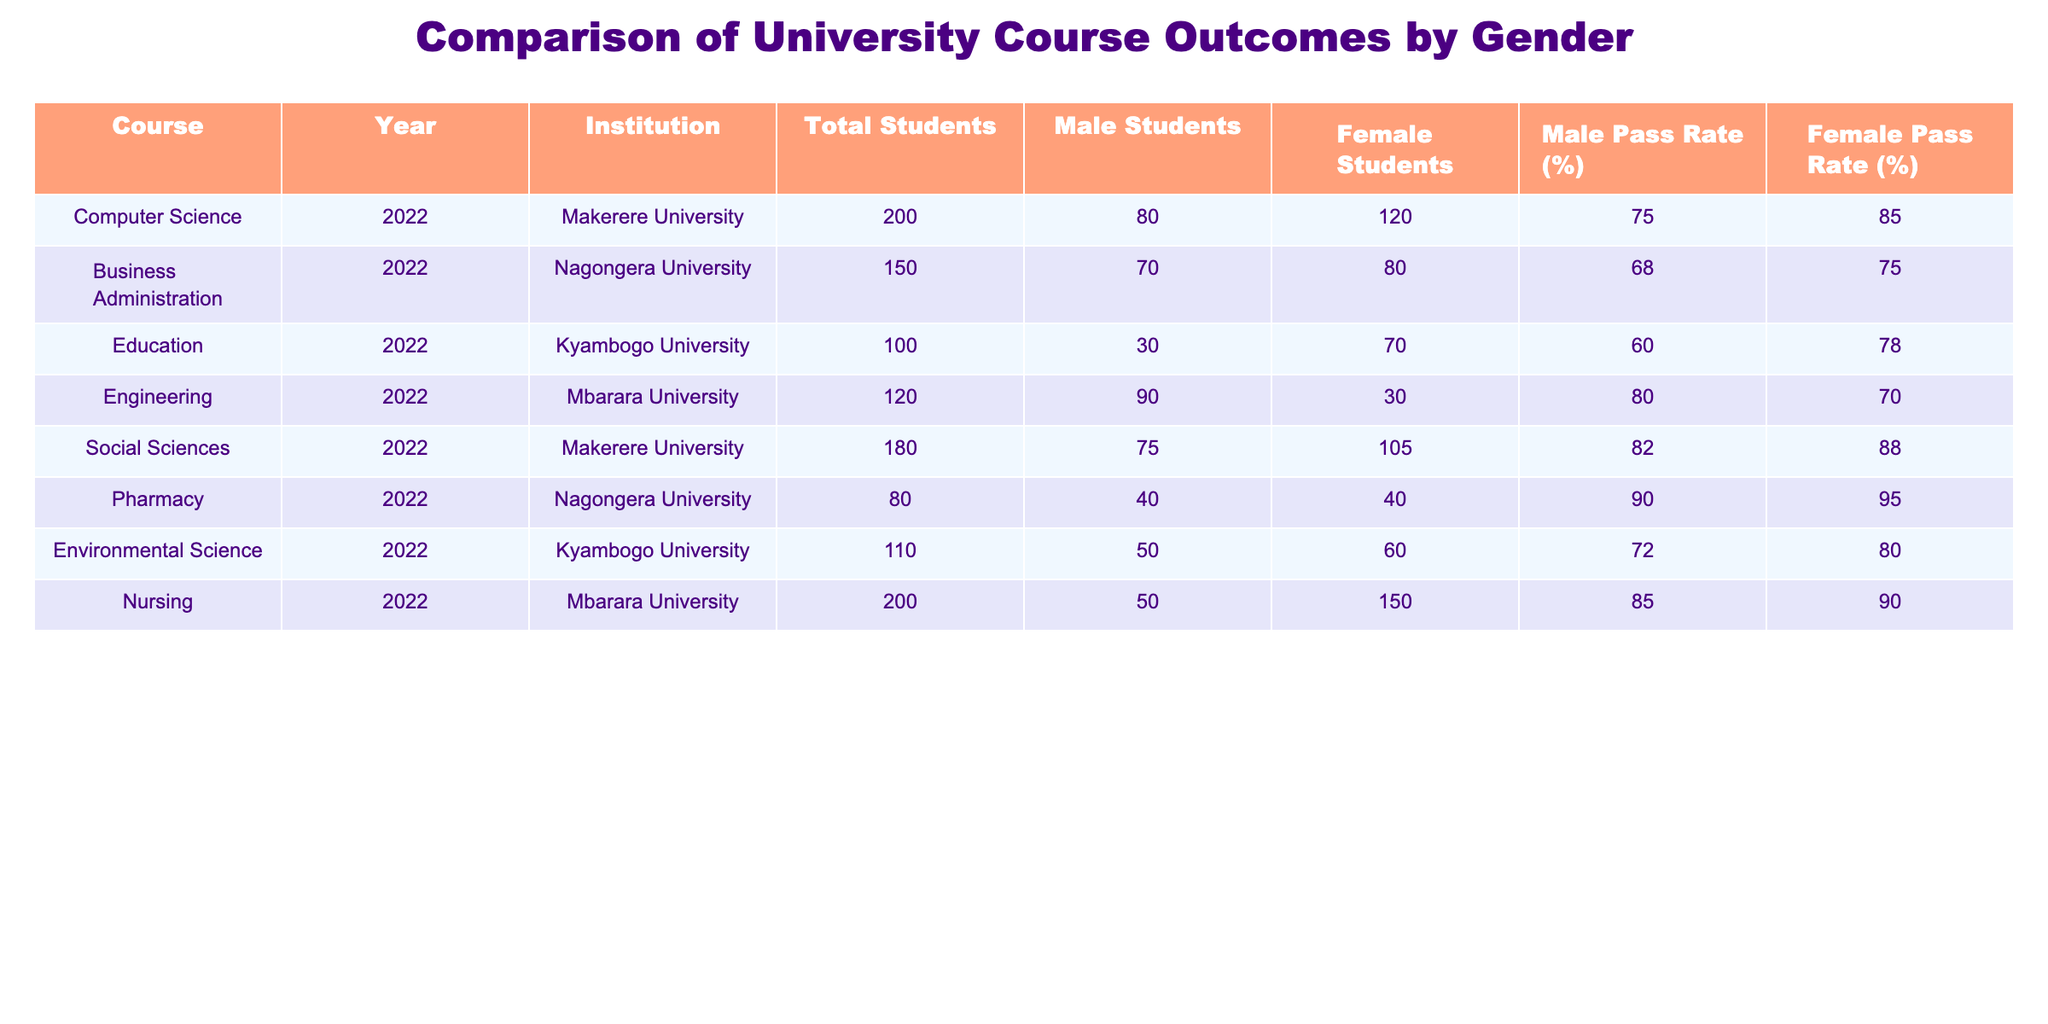What is the total number of students in the Nursing course? From the table, we can see that in the Nursing course, the "Total Students" column lists 200 students.
Answer: 200 What is the pass rate for male students in Pharmacy? In the Pharmacy course row, the "Male Pass Rate (%)" is listed as 90%.
Answer: 90% Which course has the highest female pass rate? By examining the "Female Pass Rate (%)" column, the maximum value is 95%, which corresponds to the Pharmacy course.
Answer: Pharmacy What is the average male pass rate across all courses? To find the average, we sum the male pass rates: (75 + 68 + 60 + 80 + 82 + 90 + 72 + 85) =  632. There are 8 courses, so the average is 632 / 8 = 79.
Answer: 79 Is the pass rate for female students in Education higher than that for male students in the same course? In the Education course, the female pass rate is 78%, while the male pass rate is 60%. Therefore, the female pass rate is indeed higher.
Answer: Yes How many more female students than male students are there in Social Sciences? For the Social Sciences course, there are 105 female students and 75 male students. The difference is 105 - 75 = 30.
Answer: 30 Does the Engineering course have a higher male pass rate than the overall average male pass rate of 79? The Engineering course has a male pass rate of 80%, which is higher than the average male pass rate of 79%.
Answer: Yes What is the difference between the total male students and total female students in the Business Administration course? In Business Administration, there are 70 male students and 80 female students. The difference is 80 - 70 = 10.
Answer: 10 